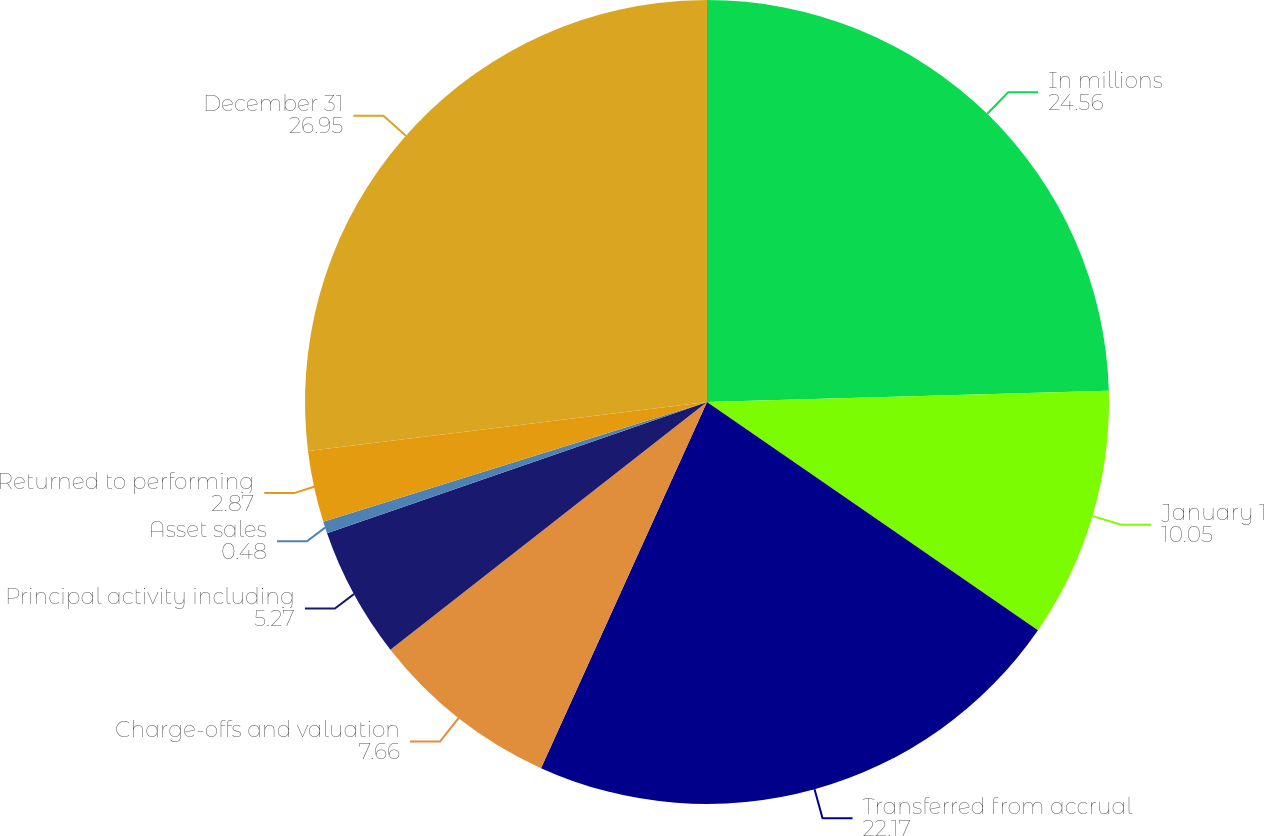<chart> <loc_0><loc_0><loc_500><loc_500><pie_chart><fcel>In millions<fcel>January 1<fcel>Transferred from accrual<fcel>Charge-offs and valuation<fcel>Principal activity including<fcel>Asset sales<fcel>Returned to performing<fcel>December 31<nl><fcel>24.56%<fcel>10.05%<fcel>22.17%<fcel>7.66%<fcel>5.27%<fcel>0.48%<fcel>2.87%<fcel>26.95%<nl></chart> 